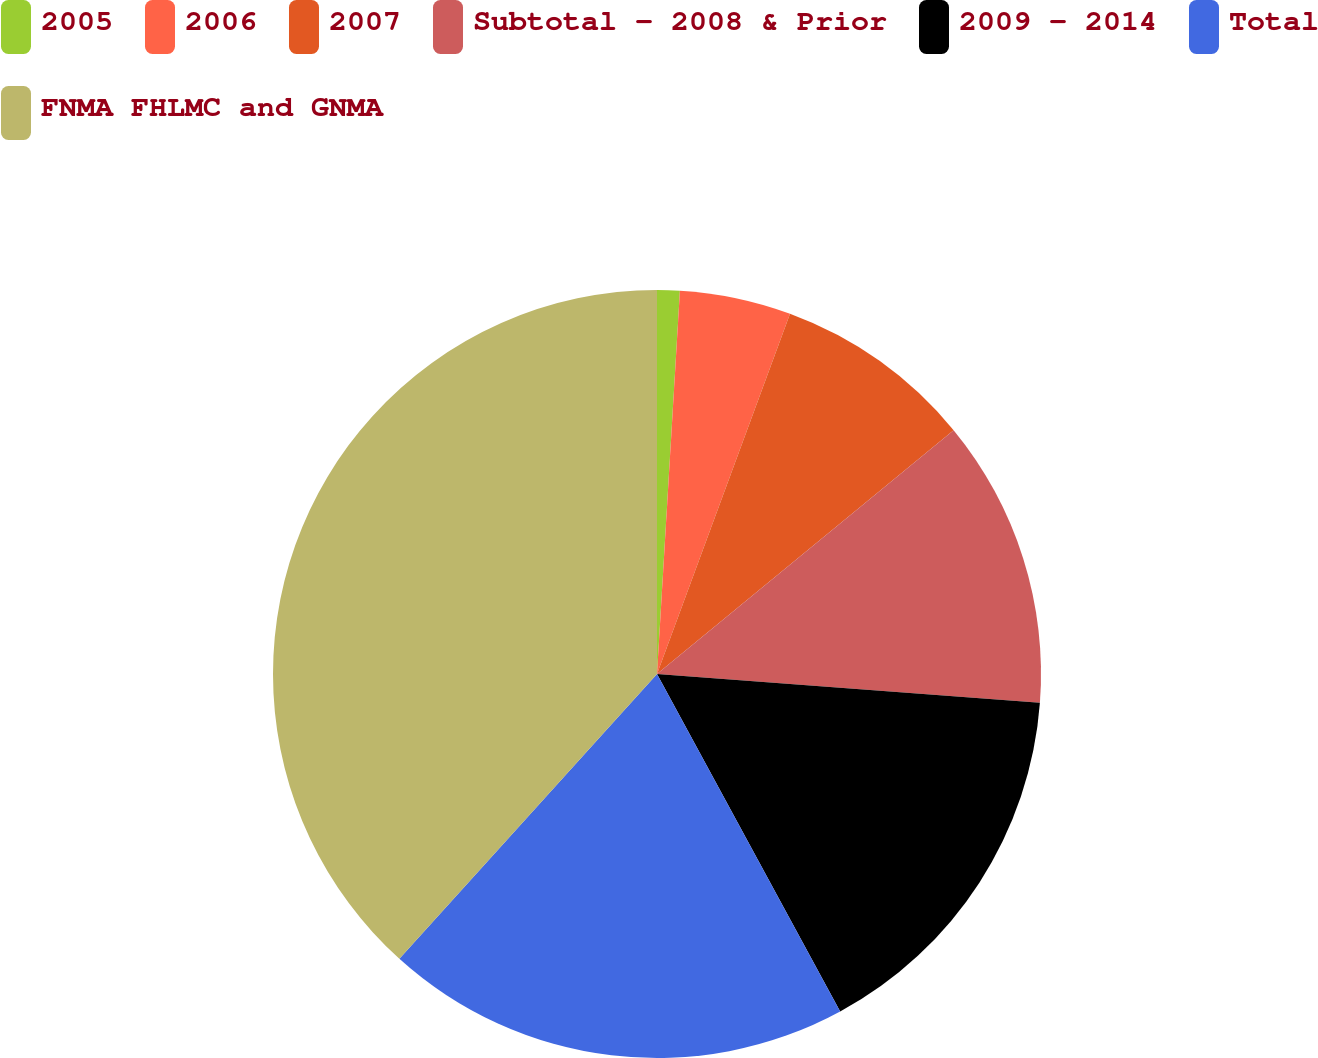<chart> <loc_0><loc_0><loc_500><loc_500><pie_chart><fcel>2005<fcel>2006<fcel>2007<fcel>Subtotal - 2008 & Prior<fcel>2009 - 2014<fcel>Total<fcel>FNMA FHLMC and GNMA<nl><fcel>0.95%<fcel>4.68%<fcel>8.42%<fcel>12.15%<fcel>15.89%<fcel>19.62%<fcel>38.3%<nl></chart> 